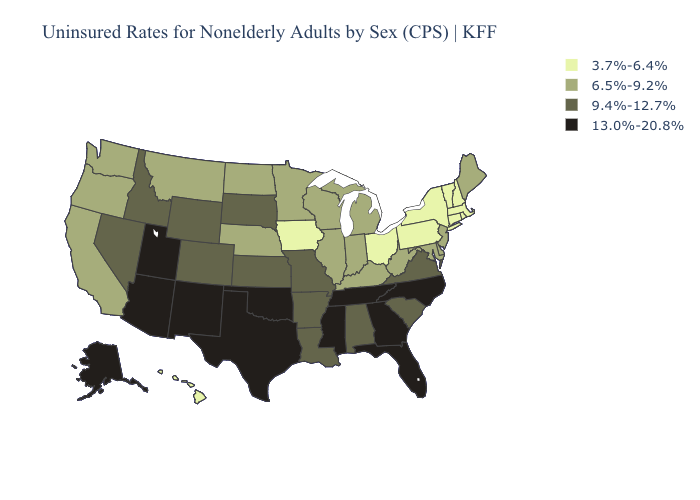Which states have the highest value in the USA?
Write a very short answer. Alaska, Arizona, Florida, Georgia, Mississippi, New Mexico, North Carolina, Oklahoma, Tennessee, Texas, Utah. Among the states that border Illinois , which have the lowest value?
Short answer required. Iowa. Does Tennessee have the same value as Pennsylvania?
Write a very short answer. No. What is the value of Virginia?
Concise answer only. 9.4%-12.7%. What is the value of Arkansas?
Keep it brief. 9.4%-12.7%. Among the states that border Wisconsin , does Iowa have the lowest value?
Concise answer only. Yes. What is the lowest value in the USA?
Keep it brief. 3.7%-6.4%. Is the legend a continuous bar?
Keep it brief. No. Does Kentucky have the lowest value in the South?
Short answer required. Yes. Name the states that have a value in the range 6.5%-9.2%?
Answer briefly. California, Delaware, Illinois, Indiana, Kentucky, Maine, Maryland, Michigan, Minnesota, Montana, Nebraska, New Jersey, North Dakota, Oregon, Washington, West Virginia, Wisconsin. What is the highest value in the Northeast ?
Short answer required. 6.5%-9.2%. Does the map have missing data?
Concise answer only. No. Name the states that have a value in the range 9.4%-12.7%?
Give a very brief answer. Alabama, Arkansas, Colorado, Idaho, Kansas, Louisiana, Missouri, Nevada, South Carolina, South Dakota, Virginia, Wyoming. What is the value of Tennessee?
Write a very short answer. 13.0%-20.8%. 